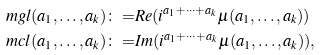<formula> <loc_0><loc_0><loc_500><loc_500>\ m g l ( a _ { 1 } , \dots , a _ { k } ) \colon = & R e ( i ^ { a _ { 1 } + \cdots + a _ { k } } \mu ( a _ { 1 } , \dots , a _ { k } ) ) \\ \ m c l ( a _ { 1 } , \dots , a _ { k } ) \colon = & I m ( i ^ { a _ { 1 } + \cdots + a _ { k } } \mu ( a _ { 1 } , \dots , a _ { k } ) ) ,</formula> 